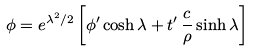Convert formula to latex. <formula><loc_0><loc_0><loc_500><loc_500>\phi = e ^ { \lambda ^ { 2 } / 2 } \left [ \phi ^ { \prime } \cosh { \lambda } + t ^ { \prime } \, \frac { c } { \rho } \sinh { \lambda } \right ]</formula> 